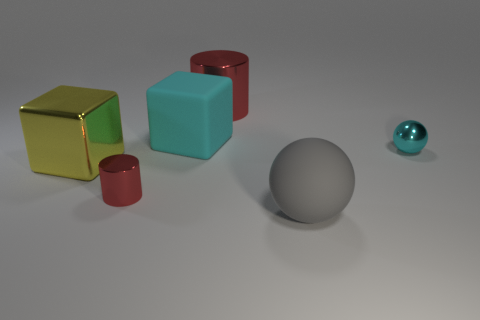Add 1 large cyan things. How many objects exist? 7 Subtract all balls. How many objects are left? 4 Add 4 large red shiny objects. How many large red shiny objects exist? 5 Subtract 1 cyan blocks. How many objects are left? 5 Subtract all large red objects. Subtract all large matte blocks. How many objects are left? 4 Add 4 balls. How many balls are left? 6 